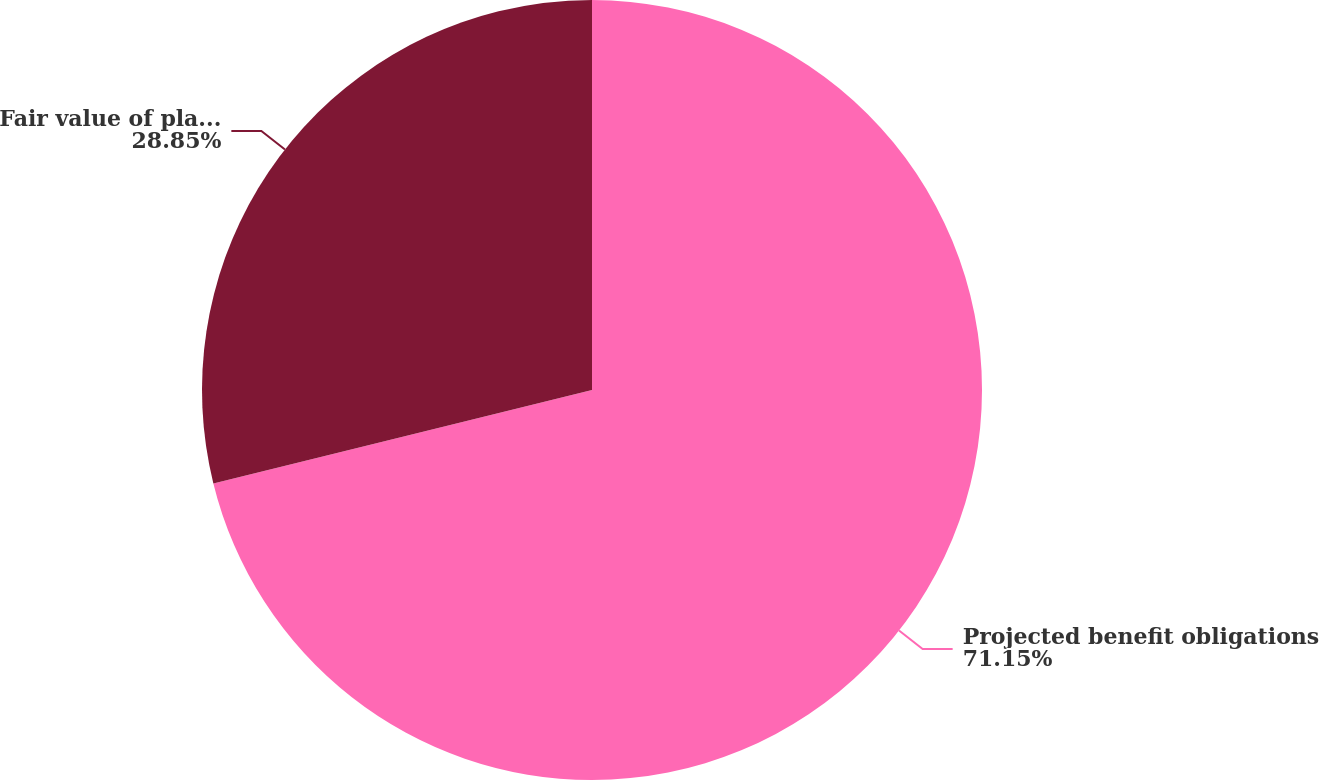<chart> <loc_0><loc_0><loc_500><loc_500><pie_chart><fcel>Projected benefit obligations<fcel>Fair value of plan assets<nl><fcel>71.15%<fcel>28.85%<nl></chart> 